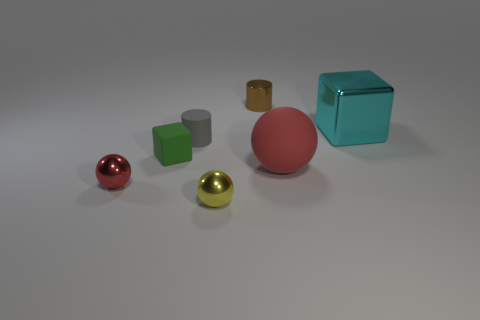Add 2 yellow shiny balls. How many objects exist? 9 Subtract all cubes. How many objects are left? 5 Subtract all big cyan cubes. Subtract all rubber objects. How many objects are left? 3 Add 6 blocks. How many blocks are left? 8 Add 7 red metal balls. How many red metal balls exist? 8 Subtract 0 red cylinders. How many objects are left? 7 